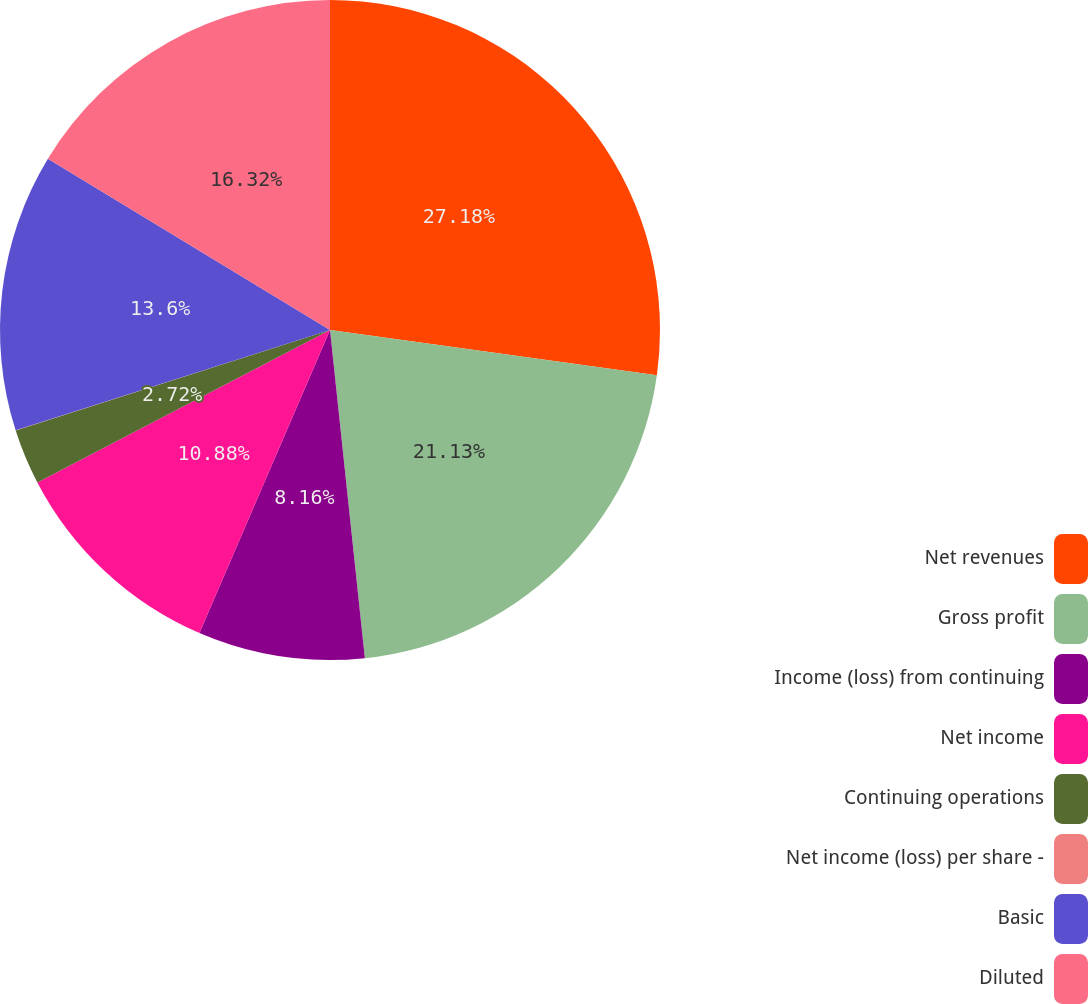<chart> <loc_0><loc_0><loc_500><loc_500><pie_chart><fcel>Net revenues<fcel>Gross profit<fcel>Income (loss) from continuing<fcel>Net income<fcel>Continuing operations<fcel>Net income (loss) per share -<fcel>Basic<fcel>Diluted<nl><fcel>27.19%<fcel>21.13%<fcel>8.16%<fcel>10.88%<fcel>2.72%<fcel>0.01%<fcel>13.6%<fcel>16.32%<nl></chart> 